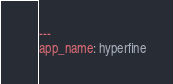Convert code to text. <code><loc_0><loc_0><loc_500><loc_500><_YAML_>---
app_name: hyperfine
</code> 